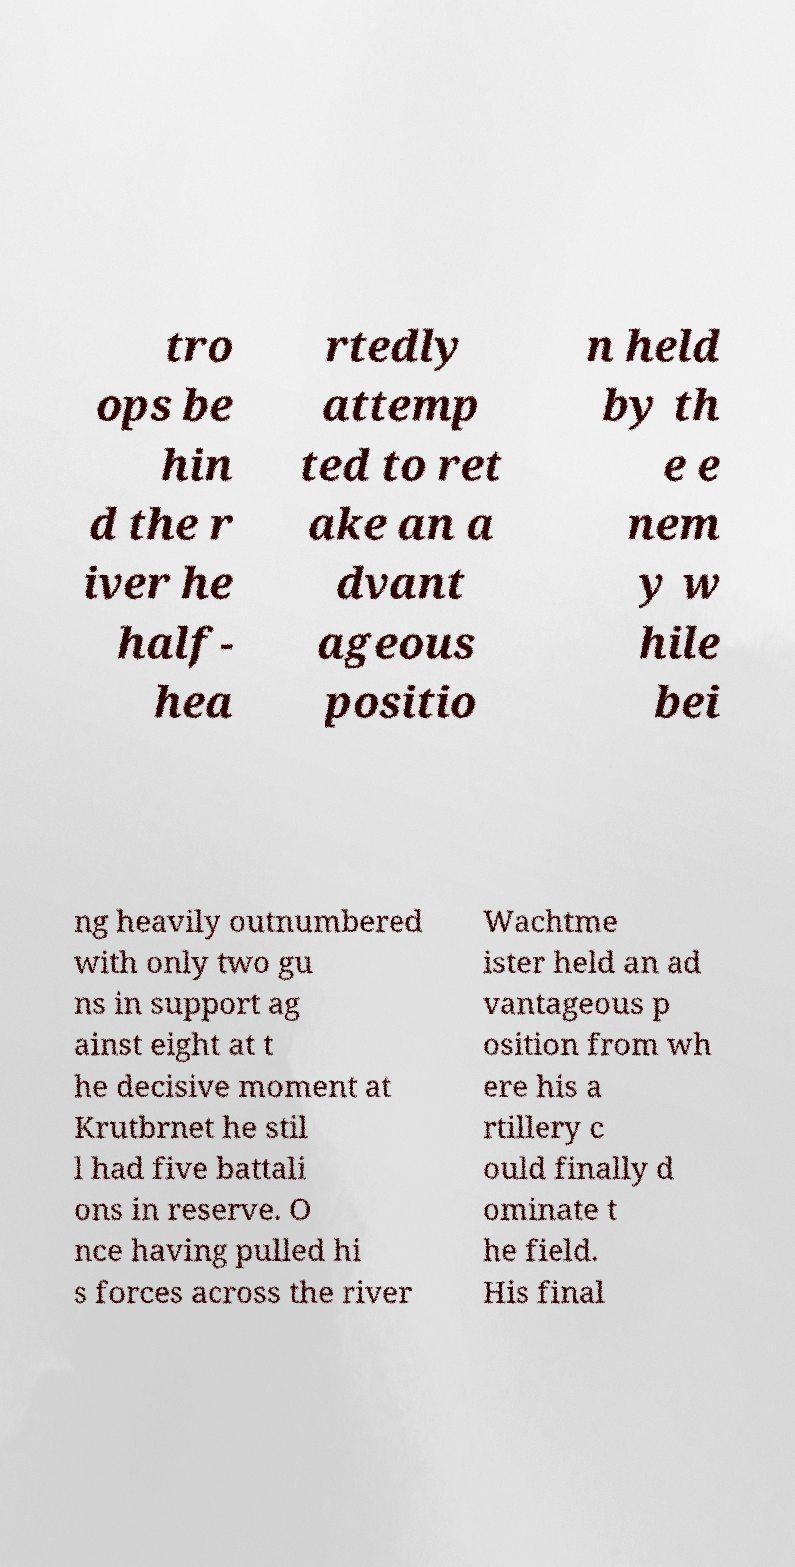I need the written content from this picture converted into text. Can you do that? tro ops be hin d the r iver he half- hea rtedly attemp ted to ret ake an a dvant ageous positio n held by th e e nem y w hile bei ng heavily outnumbered with only two gu ns in support ag ainst eight at t he decisive moment at Krutbrnet he stil l had five battali ons in reserve. O nce having pulled hi s forces across the river Wachtme ister held an ad vantageous p osition from wh ere his a rtillery c ould finally d ominate t he field. His final 